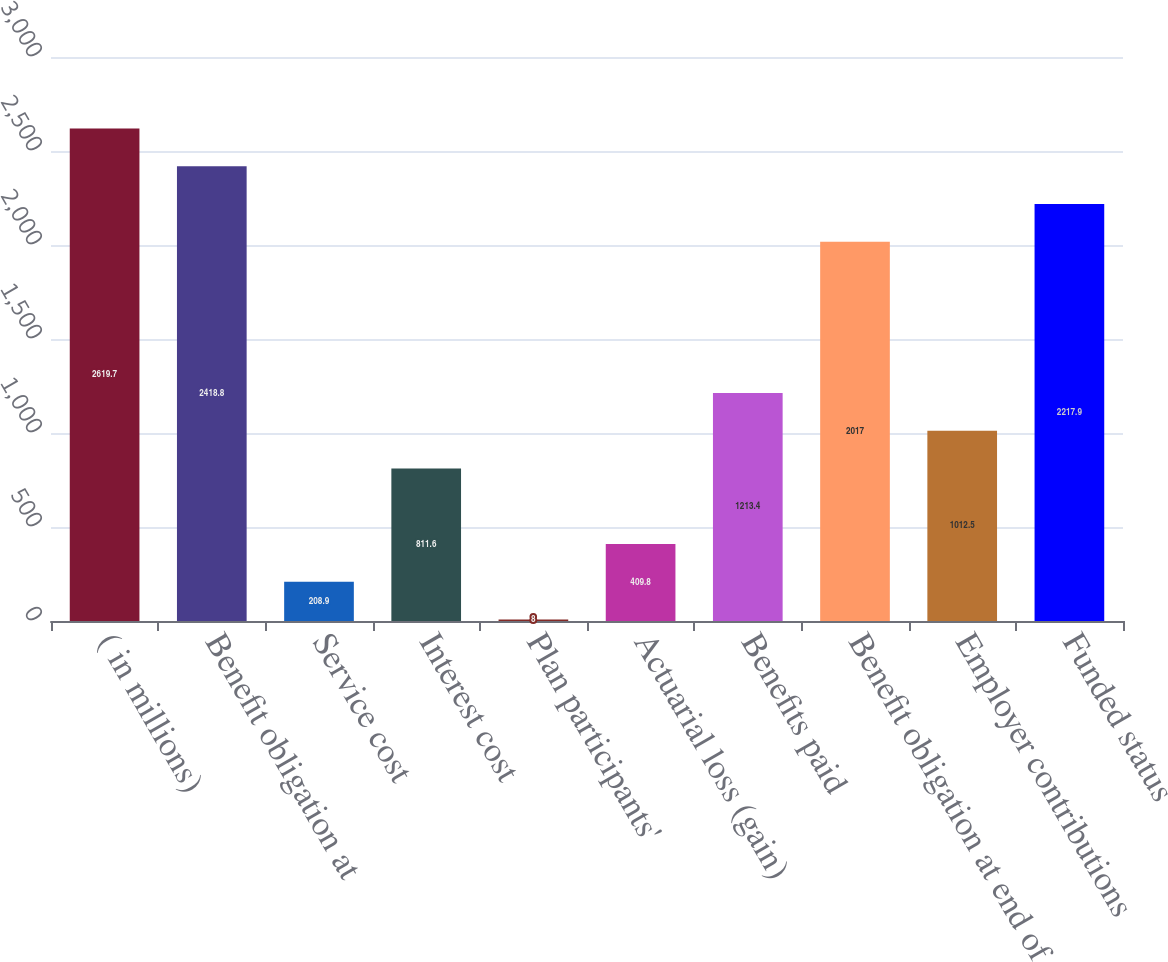Convert chart to OTSL. <chart><loc_0><loc_0><loc_500><loc_500><bar_chart><fcel>( in millions)<fcel>Benefit obligation at<fcel>Service cost<fcel>Interest cost<fcel>Plan participants'<fcel>Actuarial loss (gain)<fcel>Benefits paid<fcel>Benefit obligation at end of<fcel>Employer contributions<fcel>Funded status<nl><fcel>2619.7<fcel>2418.8<fcel>208.9<fcel>811.6<fcel>8<fcel>409.8<fcel>1213.4<fcel>2017<fcel>1012.5<fcel>2217.9<nl></chart> 